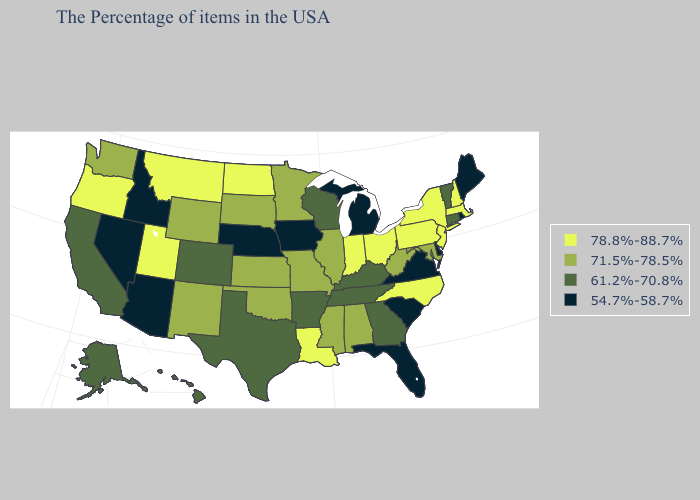Does the map have missing data?
Short answer required. No. What is the highest value in the MidWest ?
Be succinct. 78.8%-88.7%. Name the states that have a value in the range 54.7%-58.7%?
Quick response, please. Maine, Rhode Island, Delaware, Virginia, South Carolina, Florida, Michigan, Iowa, Nebraska, Arizona, Idaho, Nevada. What is the lowest value in states that border Colorado?
Write a very short answer. 54.7%-58.7%. Name the states that have a value in the range 78.8%-88.7%?
Quick response, please. Massachusetts, New Hampshire, New York, New Jersey, Pennsylvania, North Carolina, Ohio, Indiana, Louisiana, North Dakota, Utah, Montana, Oregon. What is the value of Maryland?
Keep it brief. 71.5%-78.5%. What is the value of Connecticut?
Concise answer only. 61.2%-70.8%. What is the lowest value in the South?
Write a very short answer. 54.7%-58.7%. Name the states that have a value in the range 61.2%-70.8%?
Quick response, please. Vermont, Connecticut, Georgia, Kentucky, Tennessee, Wisconsin, Arkansas, Texas, Colorado, California, Alaska, Hawaii. Name the states that have a value in the range 71.5%-78.5%?
Quick response, please. Maryland, West Virginia, Alabama, Illinois, Mississippi, Missouri, Minnesota, Kansas, Oklahoma, South Dakota, Wyoming, New Mexico, Washington. What is the value of South Dakota?
Be succinct. 71.5%-78.5%. What is the highest value in states that border Vermont?
Quick response, please. 78.8%-88.7%. What is the lowest value in states that border California?
Give a very brief answer. 54.7%-58.7%. Name the states that have a value in the range 78.8%-88.7%?
Short answer required. Massachusetts, New Hampshire, New York, New Jersey, Pennsylvania, North Carolina, Ohio, Indiana, Louisiana, North Dakota, Utah, Montana, Oregon. 